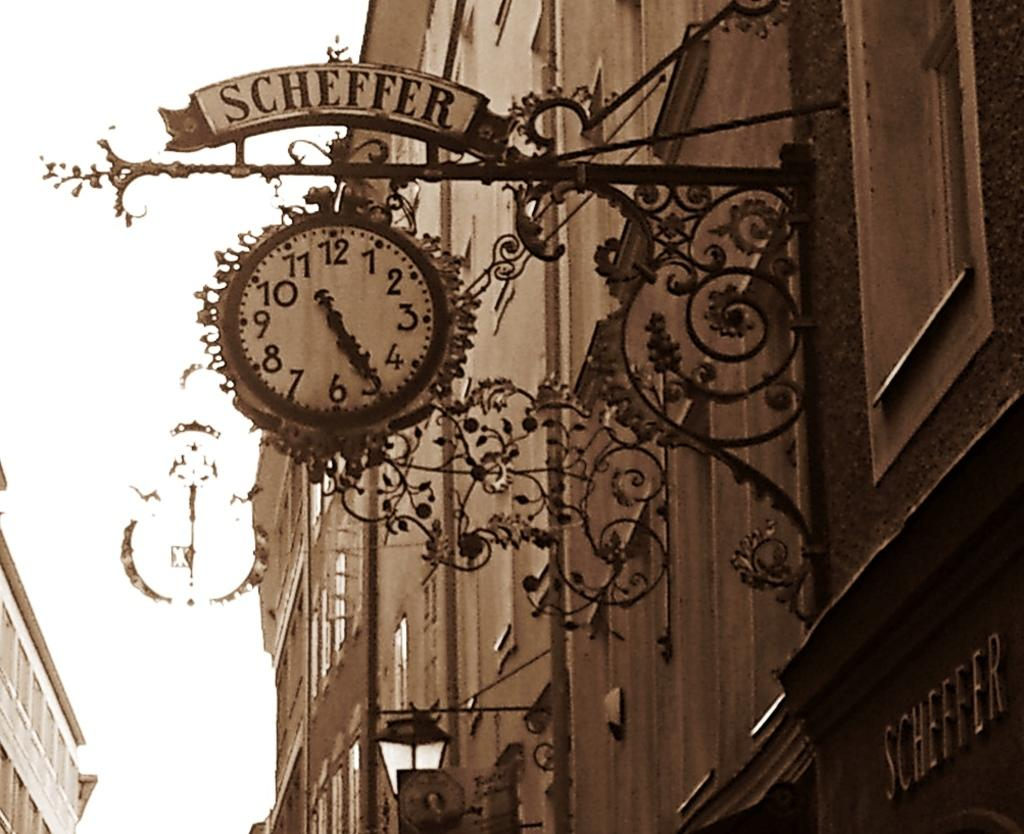<image>
Present a compact description of the photo's key features. the name scheffer that is on a sign 